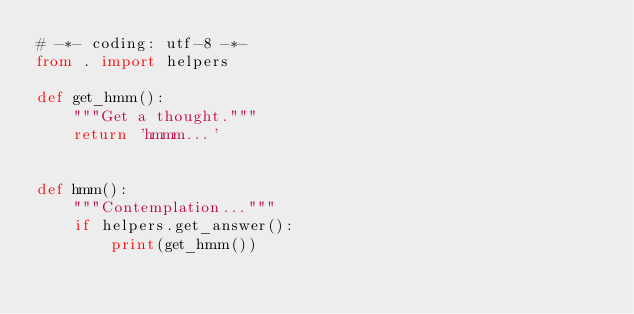<code> <loc_0><loc_0><loc_500><loc_500><_Python_># -*- coding: utf-8 -*-
from . import helpers

def get_hmm():
    """Get a thought."""
    return 'hmmm...'


def hmm():
    """Contemplation..."""
    if helpers.get_answer():
        print(get_hmm())</code> 